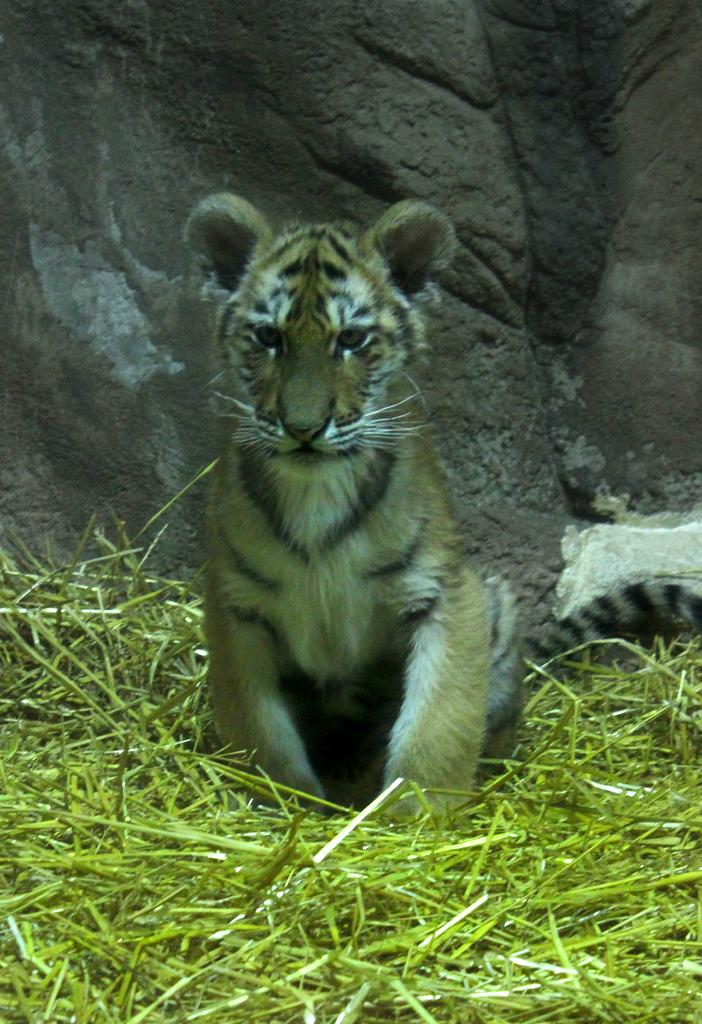What animal is in the image? There is a tiger in the image. What is the tiger doing in the image? The tiger is sitting on the grass. What can be seen in the background of the image? There is a wall in the background of the image. What is the team's tendency to win games in the image? There is no reference to a team or games in the image, so it's not possible to determine any team's tendency to win games. 